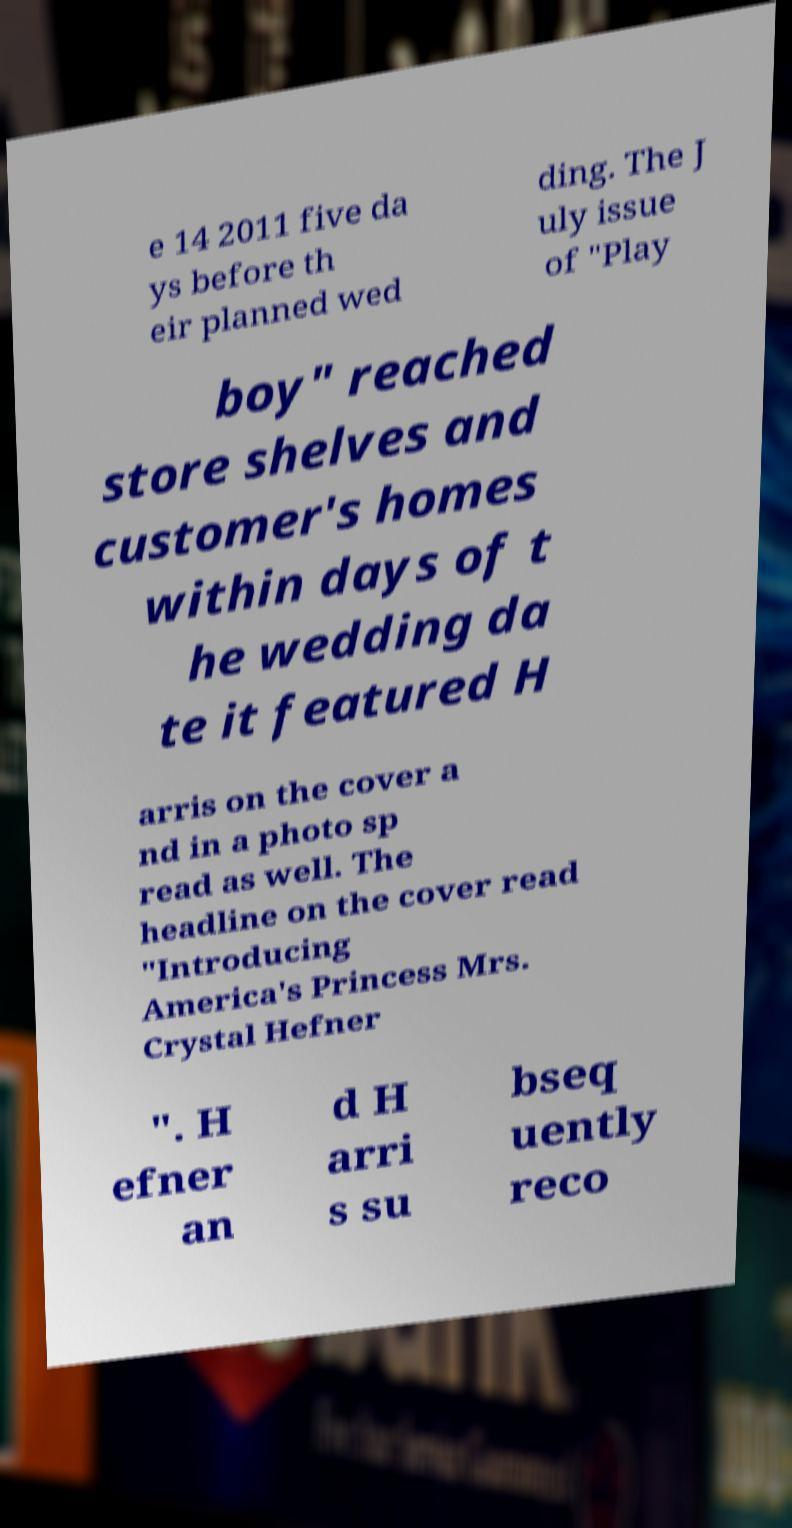What messages or text are displayed in this image? I need them in a readable, typed format. e 14 2011 five da ys before th eir planned wed ding. The J uly issue of "Play boy" reached store shelves and customer's homes within days of t he wedding da te it featured H arris on the cover a nd in a photo sp read as well. The headline on the cover read "Introducing America's Princess Mrs. Crystal Hefner ". H efner an d H arri s su bseq uently reco 